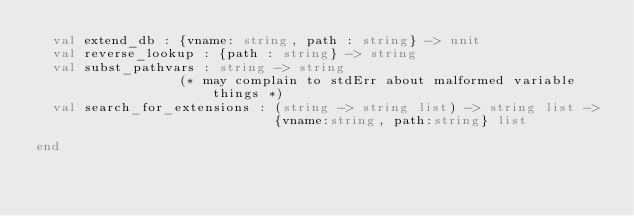<code> <loc_0><loc_0><loc_500><loc_500><_SML_>  val extend_db : {vname: string, path : string} -> unit
  val reverse_lookup : {path : string} -> string
  val subst_pathvars : string -> string
                  (* may complain to stdErr about malformed variable things *)
  val search_for_extensions : (string -> string list) -> string list ->
                              {vname:string, path:string} list

end
</code> 